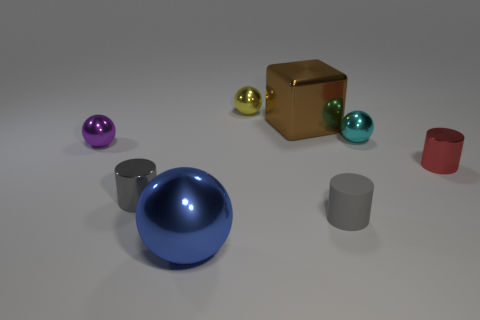What number of other tiny cylinders are the same color as the rubber cylinder?
Offer a very short reply. 1. There is a tiny object that is behind the brown metal thing; what is its shape?
Offer a very short reply. Sphere. Is the material of the big thing on the left side of the tiny yellow metal thing the same as the big thing that is behind the tiny purple thing?
Your answer should be compact. Yes. Is there a small gray rubber thing that has the same shape as the tiny purple thing?
Provide a succinct answer. No. What number of things are either yellow shiny spheres right of the large blue metallic object or big blue metallic balls?
Your answer should be very brief. 2. Is the number of purple metallic things that are in front of the big blue sphere greater than the number of red cylinders that are on the left side of the tiny gray matte cylinder?
Provide a succinct answer. No. What number of matte objects are either small yellow balls or small cyan things?
Make the answer very short. 0. There is a tiny cylinder that is the same color as the matte thing; what is it made of?
Offer a terse response. Metal. Is the number of large things that are to the right of the tiny red object less than the number of gray rubber objects on the left side of the yellow metal sphere?
Offer a terse response. No. What number of objects are gray metallic objects or large brown blocks that are behind the small gray metal cylinder?
Make the answer very short. 2. 